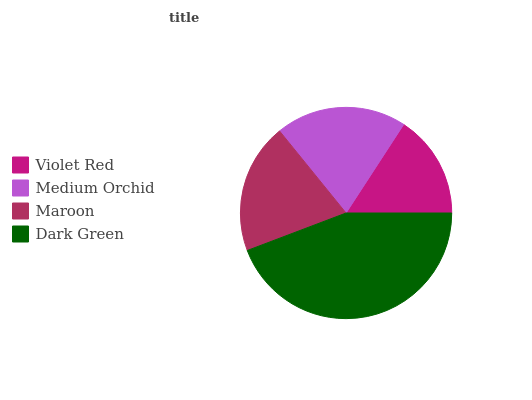Is Violet Red the minimum?
Answer yes or no. Yes. Is Dark Green the maximum?
Answer yes or no. Yes. Is Medium Orchid the minimum?
Answer yes or no. No. Is Medium Orchid the maximum?
Answer yes or no. No. Is Medium Orchid greater than Violet Red?
Answer yes or no. Yes. Is Violet Red less than Medium Orchid?
Answer yes or no. Yes. Is Violet Red greater than Medium Orchid?
Answer yes or no. No. Is Medium Orchid less than Violet Red?
Answer yes or no. No. Is Medium Orchid the high median?
Answer yes or no. Yes. Is Maroon the low median?
Answer yes or no. Yes. Is Dark Green the high median?
Answer yes or no. No. Is Dark Green the low median?
Answer yes or no. No. 